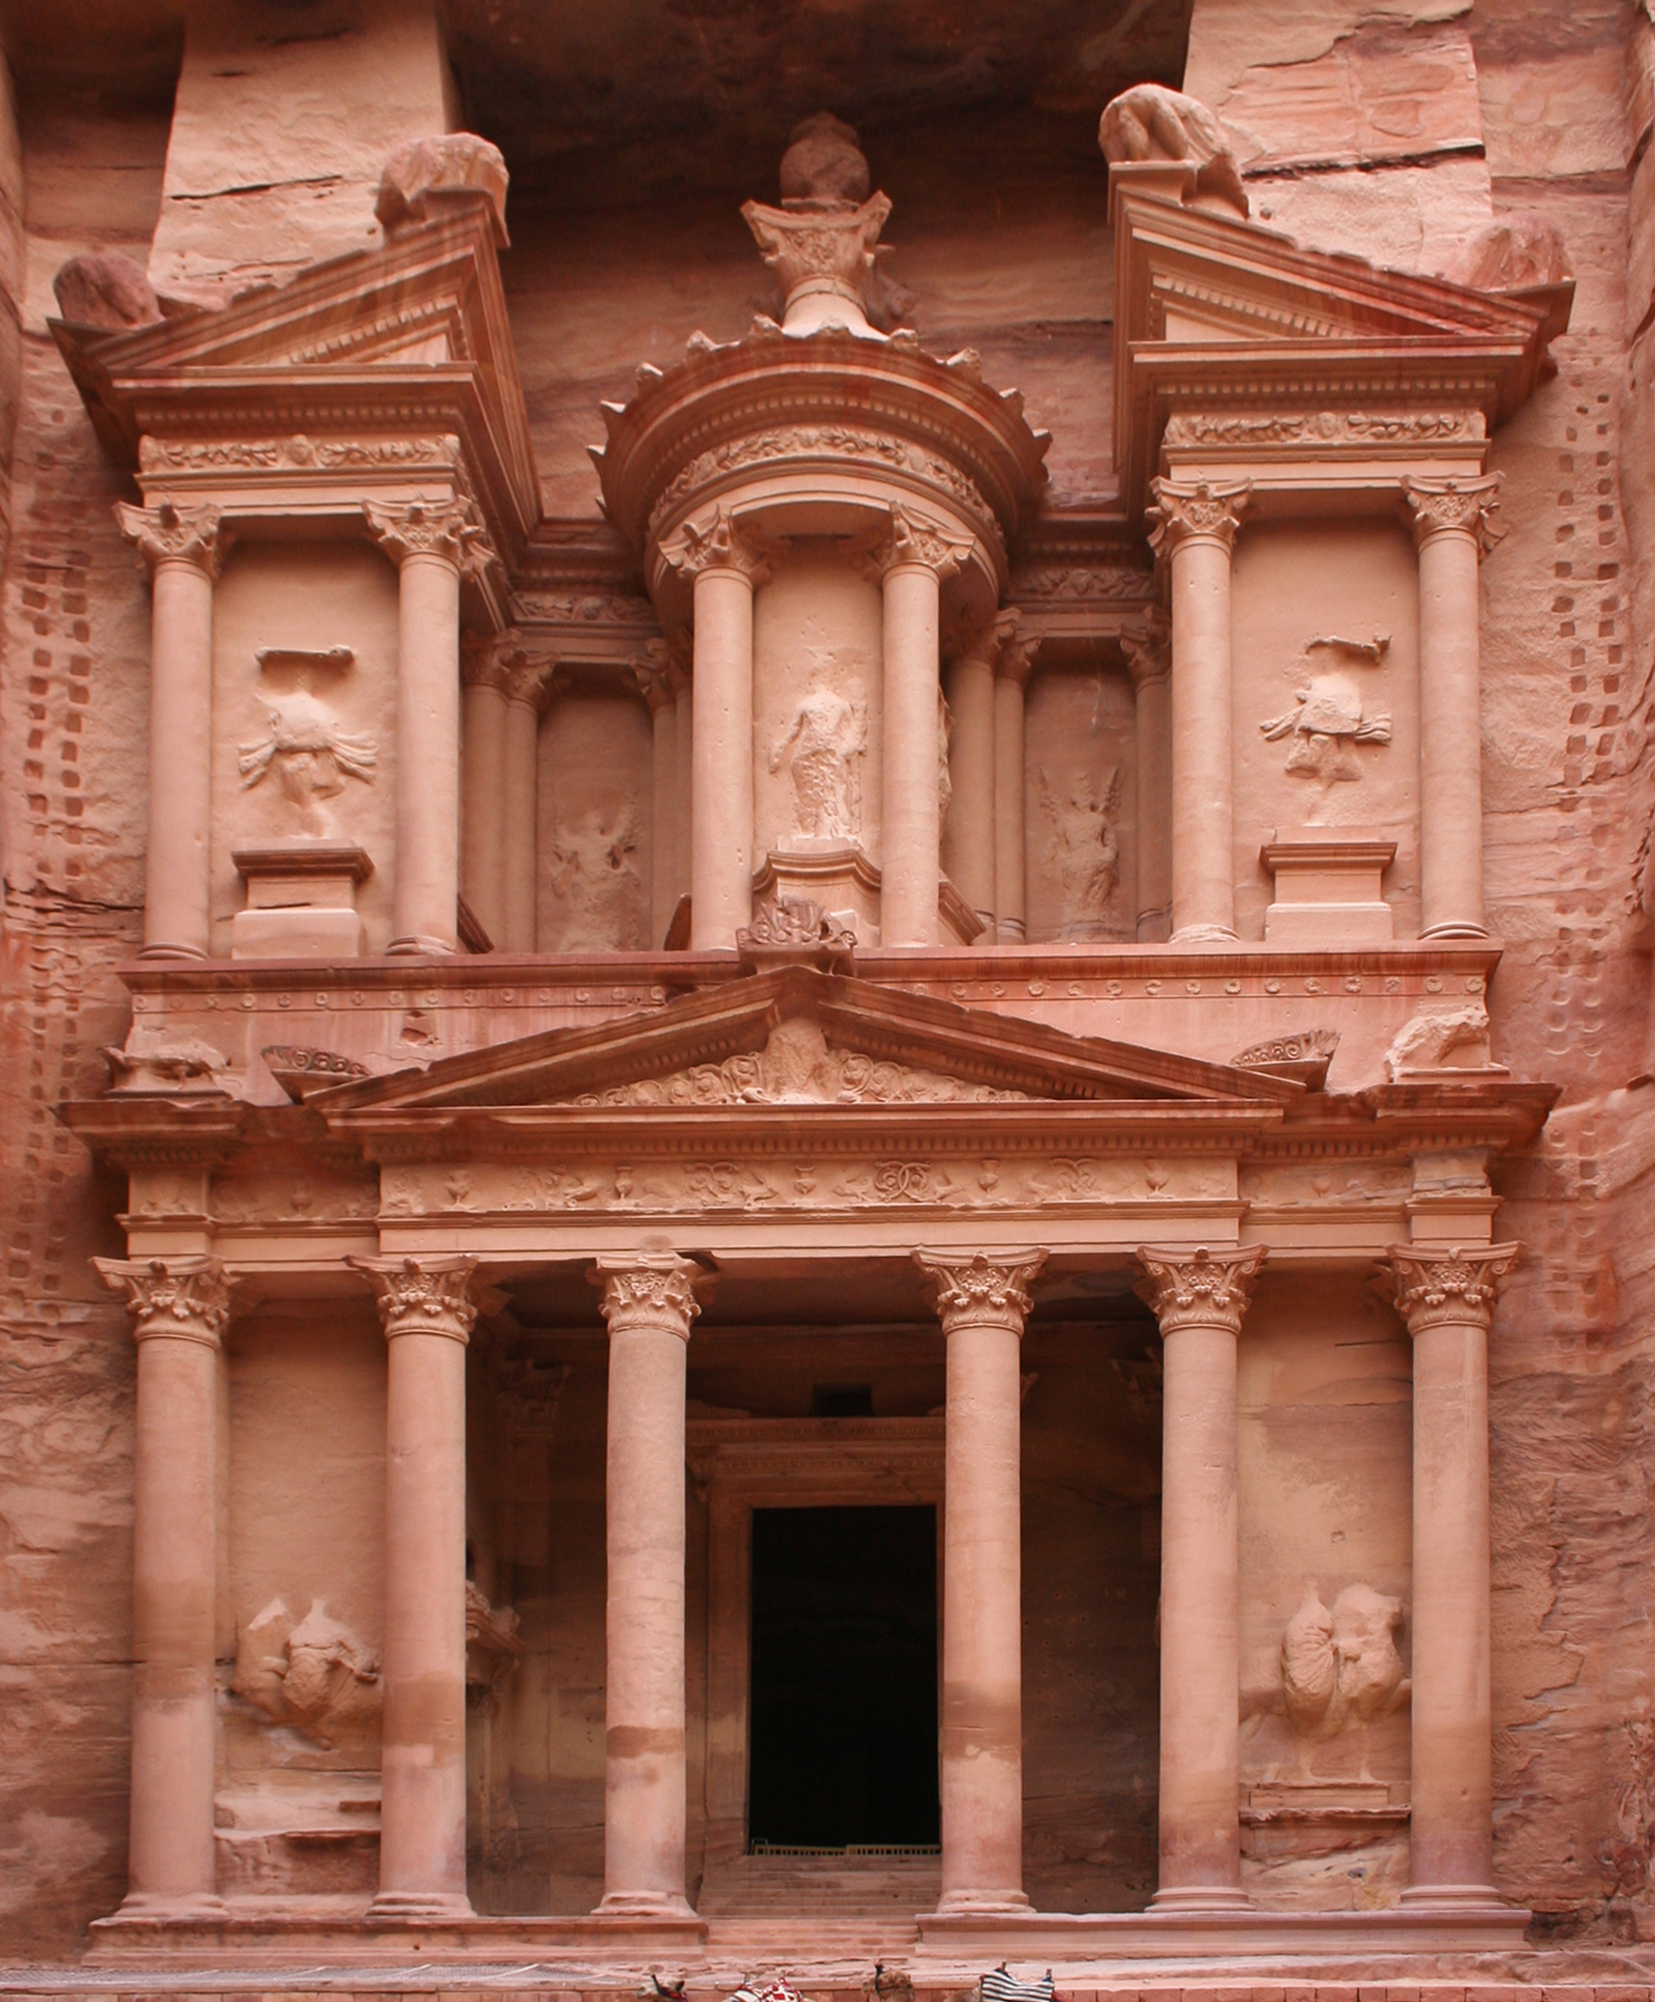What is the significance of the location of Al-Khazneh within Petra? Al-Khazneh's location at the end of a narrow gorge known as the Siq plays a significant role both strategically and ceremonially. Strategically, its hidden placement protected the temple and its treasures from potential invaders. Ceremonially, the dramatic unveiling of the Treasury upon exiting the Siq may have been designed to awe and inspire pilgrims and visitors, reinforcing the might and mystery of the Nabataean kingdom. 